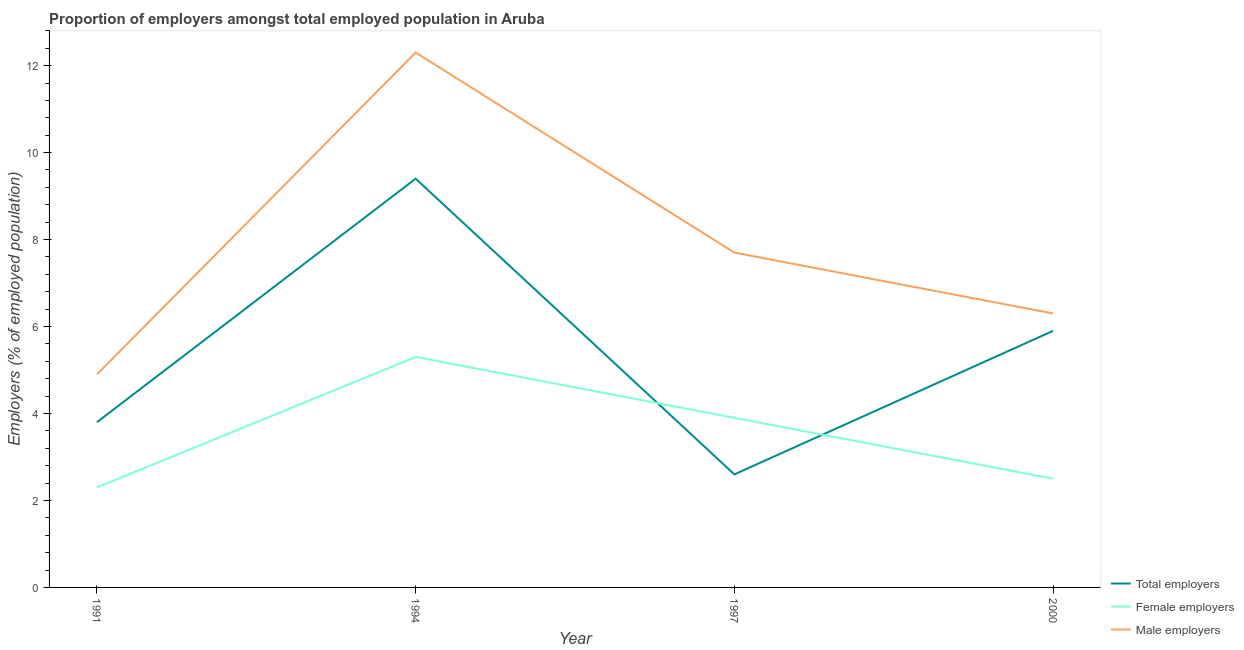Does the line corresponding to percentage of total employers intersect with the line corresponding to percentage of female employers?
Offer a terse response. Yes. Is the number of lines equal to the number of legend labels?
Offer a terse response. Yes. What is the percentage of male employers in 1994?
Give a very brief answer. 12.3. Across all years, what is the maximum percentage of male employers?
Make the answer very short. 12.3. Across all years, what is the minimum percentage of male employers?
Give a very brief answer. 4.9. What is the total percentage of female employers in the graph?
Offer a very short reply. 14. What is the difference between the percentage of female employers in 1997 and that in 2000?
Give a very brief answer. 1.4. What is the difference between the percentage of total employers in 1997 and the percentage of male employers in 2000?
Your answer should be compact. -3.7. What is the average percentage of male employers per year?
Your answer should be compact. 7.8. In the year 1997, what is the difference between the percentage of male employers and percentage of total employers?
Offer a very short reply. 5.1. What is the ratio of the percentage of female employers in 1991 to that in 1994?
Provide a succinct answer. 0.43. What is the difference between the highest and the second highest percentage of female employers?
Your response must be concise. 1.4. What is the difference between the highest and the lowest percentage of total employers?
Keep it short and to the point. 6.8. Is the sum of the percentage of male employers in 1994 and 2000 greater than the maximum percentage of female employers across all years?
Offer a very short reply. Yes. Is it the case that in every year, the sum of the percentage of total employers and percentage of female employers is greater than the percentage of male employers?
Your answer should be compact. No. Is the percentage of male employers strictly greater than the percentage of total employers over the years?
Give a very brief answer. Yes. Are the values on the major ticks of Y-axis written in scientific E-notation?
Ensure brevity in your answer.  No. Does the graph contain any zero values?
Offer a very short reply. No. Does the graph contain grids?
Your answer should be compact. No. Where does the legend appear in the graph?
Ensure brevity in your answer.  Bottom right. How many legend labels are there?
Your answer should be compact. 3. How are the legend labels stacked?
Provide a short and direct response. Vertical. What is the title of the graph?
Provide a short and direct response. Proportion of employers amongst total employed population in Aruba. Does "Spain" appear as one of the legend labels in the graph?
Your answer should be compact. No. What is the label or title of the X-axis?
Your answer should be compact. Year. What is the label or title of the Y-axis?
Make the answer very short. Employers (% of employed population). What is the Employers (% of employed population) of Total employers in 1991?
Offer a terse response. 3.8. What is the Employers (% of employed population) of Female employers in 1991?
Ensure brevity in your answer.  2.3. What is the Employers (% of employed population) of Male employers in 1991?
Make the answer very short. 4.9. What is the Employers (% of employed population) of Total employers in 1994?
Your answer should be very brief. 9.4. What is the Employers (% of employed population) in Female employers in 1994?
Give a very brief answer. 5.3. What is the Employers (% of employed population) of Male employers in 1994?
Give a very brief answer. 12.3. What is the Employers (% of employed population) of Total employers in 1997?
Offer a terse response. 2.6. What is the Employers (% of employed population) in Female employers in 1997?
Your response must be concise. 3.9. What is the Employers (% of employed population) in Male employers in 1997?
Offer a very short reply. 7.7. What is the Employers (% of employed population) in Total employers in 2000?
Your answer should be compact. 5.9. What is the Employers (% of employed population) of Male employers in 2000?
Make the answer very short. 6.3. Across all years, what is the maximum Employers (% of employed population) of Total employers?
Ensure brevity in your answer.  9.4. Across all years, what is the maximum Employers (% of employed population) of Female employers?
Offer a very short reply. 5.3. Across all years, what is the maximum Employers (% of employed population) of Male employers?
Your answer should be compact. 12.3. Across all years, what is the minimum Employers (% of employed population) of Total employers?
Provide a succinct answer. 2.6. Across all years, what is the minimum Employers (% of employed population) of Female employers?
Ensure brevity in your answer.  2.3. Across all years, what is the minimum Employers (% of employed population) in Male employers?
Ensure brevity in your answer.  4.9. What is the total Employers (% of employed population) of Total employers in the graph?
Offer a terse response. 21.7. What is the total Employers (% of employed population) of Female employers in the graph?
Your answer should be very brief. 14. What is the total Employers (% of employed population) in Male employers in the graph?
Your answer should be very brief. 31.2. What is the difference between the Employers (% of employed population) in Female employers in 1991 and that in 1994?
Your response must be concise. -3. What is the difference between the Employers (% of employed population) in Male employers in 1991 and that in 1994?
Keep it short and to the point. -7.4. What is the difference between the Employers (% of employed population) of Total employers in 1991 and that in 1997?
Keep it short and to the point. 1.2. What is the difference between the Employers (% of employed population) of Female employers in 1991 and that in 2000?
Your answer should be compact. -0.2. What is the difference between the Employers (% of employed population) in Male employers in 1991 and that in 2000?
Give a very brief answer. -1.4. What is the difference between the Employers (% of employed population) in Total employers in 1994 and that in 1997?
Your response must be concise. 6.8. What is the difference between the Employers (% of employed population) of Female employers in 1994 and that in 1997?
Offer a terse response. 1.4. What is the difference between the Employers (% of employed population) in Male employers in 1994 and that in 1997?
Provide a short and direct response. 4.6. What is the difference between the Employers (% of employed population) of Total employers in 1994 and that in 2000?
Provide a short and direct response. 3.5. What is the difference between the Employers (% of employed population) in Female employers in 1994 and that in 2000?
Your answer should be very brief. 2.8. What is the difference between the Employers (% of employed population) in Male employers in 1997 and that in 2000?
Provide a succinct answer. 1.4. What is the difference between the Employers (% of employed population) of Total employers in 1991 and the Employers (% of employed population) of Female employers in 1994?
Offer a very short reply. -1.5. What is the difference between the Employers (% of employed population) of Total employers in 1991 and the Employers (% of employed population) of Male employers in 1994?
Give a very brief answer. -8.5. What is the difference between the Employers (% of employed population) in Female employers in 1991 and the Employers (% of employed population) in Male employers in 1994?
Offer a terse response. -10. What is the difference between the Employers (% of employed population) in Total employers in 1991 and the Employers (% of employed population) in Female employers in 1997?
Make the answer very short. -0.1. What is the difference between the Employers (% of employed population) in Total employers in 1991 and the Employers (% of employed population) in Male employers in 1997?
Your response must be concise. -3.9. What is the difference between the Employers (% of employed population) of Total employers in 1991 and the Employers (% of employed population) of Female employers in 2000?
Provide a short and direct response. 1.3. What is the difference between the Employers (% of employed population) of Female employers in 1991 and the Employers (% of employed population) of Male employers in 2000?
Offer a very short reply. -4. What is the difference between the Employers (% of employed population) in Total employers in 1994 and the Employers (% of employed population) in Female employers in 1997?
Provide a short and direct response. 5.5. What is the difference between the Employers (% of employed population) of Total employers in 1994 and the Employers (% of employed population) of Male employers in 1997?
Provide a short and direct response. 1.7. What is the difference between the Employers (% of employed population) of Total employers in 1994 and the Employers (% of employed population) of Female employers in 2000?
Keep it short and to the point. 6.9. What is the difference between the Employers (% of employed population) in Total employers in 1994 and the Employers (% of employed population) in Male employers in 2000?
Your answer should be very brief. 3.1. What is the difference between the Employers (% of employed population) of Female employers in 1994 and the Employers (% of employed population) of Male employers in 2000?
Your answer should be compact. -1. What is the difference between the Employers (% of employed population) in Total employers in 1997 and the Employers (% of employed population) in Female employers in 2000?
Keep it short and to the point. 0.1. What is the difference between the Employers (% of employed population) of Female employers in 1997 and the Employers (% of employed population) of Male employers in 2000?
Offer a terse response. -2.4. What is the average Employers (% of employed population) of Total employers per year?
Provide a succinct answer. 5.42. In the year 1991, what is the difference between the Employers (% of employed population) of Total employers and Employers (% of employed population) of Female employers?
Your response must be concise. 1.5. In the year 1991, what is the difference between the Employers (% of employed population) of Total employers and Employers (% of employed population) of Male employers?
Your answer should be compact. -1.1. In the year 1991, what is the difference between the Employers (% of employed population) of Female employers and Employers (% of employed population) of Male employers?
Keep it short and to the point. -2.6. In the year 1994, what is the difference between the Employers (% of employed population) of Total employers and Employers (% of employed population) of Female employers?
Offer a very short reply. 4.1. In the year 1994, what is the difference between the Employers (% of employed population) in Total employers and Employers (% of employed population) in Male employers?
Ensure brevity in your answer.  -2.9. In the year 1994, what is the difference between the Employers (% of employed population) of Female employers and Employers (% of employed population) of Male employers?
Your response must be concise. -7. In the year 2000, what is the difference between the Employers (% of employed population) in Total employers and Employers (% of employed population) in Male employers?
Your answer should be very brief. -0.4. What is the ratio of the Employers (% of employed population) in Total employers in 1991 to that in 1994?
Your response must be concise. 0.4. What is the ratio of the Employers (% of employed population) in Female employers in 1991 to that in 1994?
Provide a succinct answer. 0.43. What is the ratio of the Employers (% of employed population) in Male employers in 1991 to that in 1994?
Provide a succinct answer. 0.4. What is the ratio of the Employers (% of employed population) of Total employers in 1991 to that in 1997?
Your response must be concise. 1.46. What is the ratio of the Employers (% of employed population) in Female employers in 1991 to that in 1997?
Offer a terse response. 0.59. What is the ratio of the Employers (% of employed population) of Male employers in 1991 to that in 1997?
Give a very brief answer. 0.64. What is the ratio of the Employers (% of employed population) of Total employers in 1991 to that in 2000?
Ensure brevity in your answer.  0.64. What is the ratio of the Employers (% of employed population) of Male employers in 1991 to that in 2000?
Keep it short and to the point. 0.78. What is the ratio of the Employers (% of employed population) in Total employers in 1994 to that in 1997?
Ensure brevity in your answer.  3.62. What is the ratio of the Employers (% of employed population) in Female employers in 1994 to that in 1997?
Ensure brevity in your answer.  1.36. What is the ratio of the Employers (% of employed population) in Male employers in 1994 to that in 1997?
Make the answer very short. 1.6. What is the ratio of the Employers (% of employed population) in Total employers in 1994 to that in 2000?
Make the answer very short. 1.59. What is the ratio of the Employers (% of employed population) of Female employers in 1994 to that in 2000?
Give a very brief answer. 2.12. What is the ratio of the Employers (% of employed population) of Male employers in 1994 to that in 2000?
Your answer should be compact. 1.95. What is the ratio of the Employers (% of employed population) in Total employers in 1997 to that in 2000?
Provide a short and direct response. 0.44. What is the ratio of the Employers (% of employed population) of Female employers in 1997 to that in 2000?
Ensure brevity in your answer.  1.56. What is the ratio of the Employers (% of employed population) of Male employers in 1997 to that in 2000?
Offer a very short reply. 1.22. What is the difference between the highest and the lowest Employers (% of employed population) in Total employers?
Make the answer very short. 6.8. 